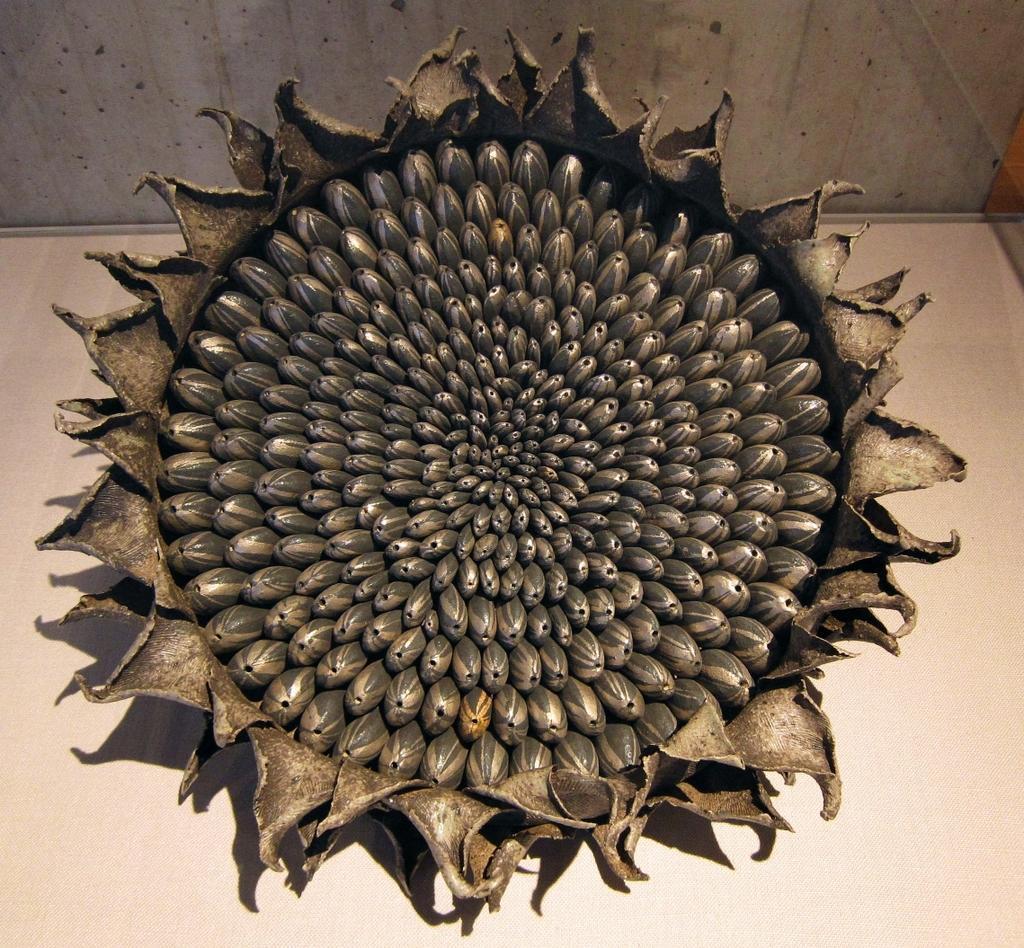Please provide a concise description of this image. In the picture I can see a dry sunflower is placed on the surface. In the background, I can see the wall. 